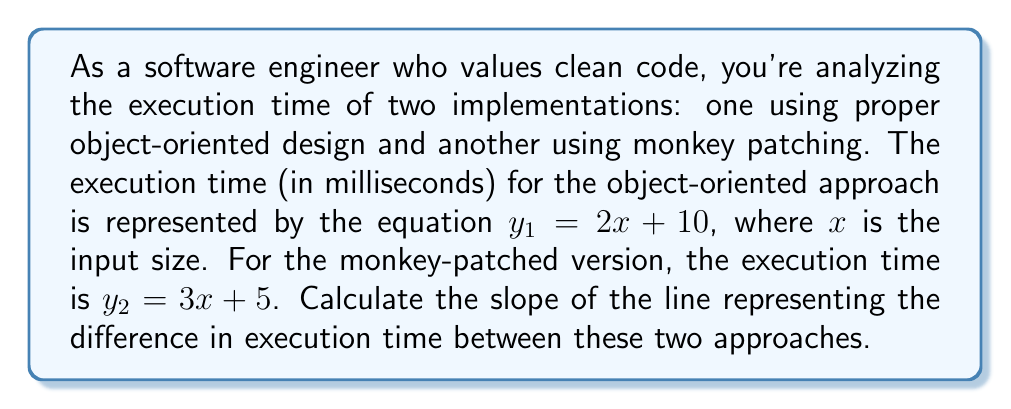Solve this math problem. Let's approach this step-by-step:

1) The execution time difference can be represented as $y_2 - y_1$:

   $y_2 - y_1 = (3x + 5) - (2x + 10)$

2) Simplify the right side of the equation:

   $y_2 - y_1 = 3x + 5 - 2x - 10$
   $y_2 - y_1 = x - 5$

3) Now we have the equation of the line representing the difference in execution time:

   $y = x - 5$

4) The slope of a line in the form $y = mx + b$ is the coefficient of $x$, which is $m$.

5) In our equation $y = x - 5$, the coefficient of $x$ is 1.

Therefore, the slope of the line representing the difference in execution time is 1.
Answer: 1 